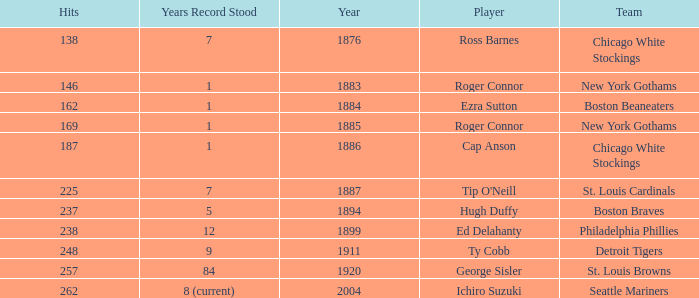Name the hits for years before 1883 138.0. 